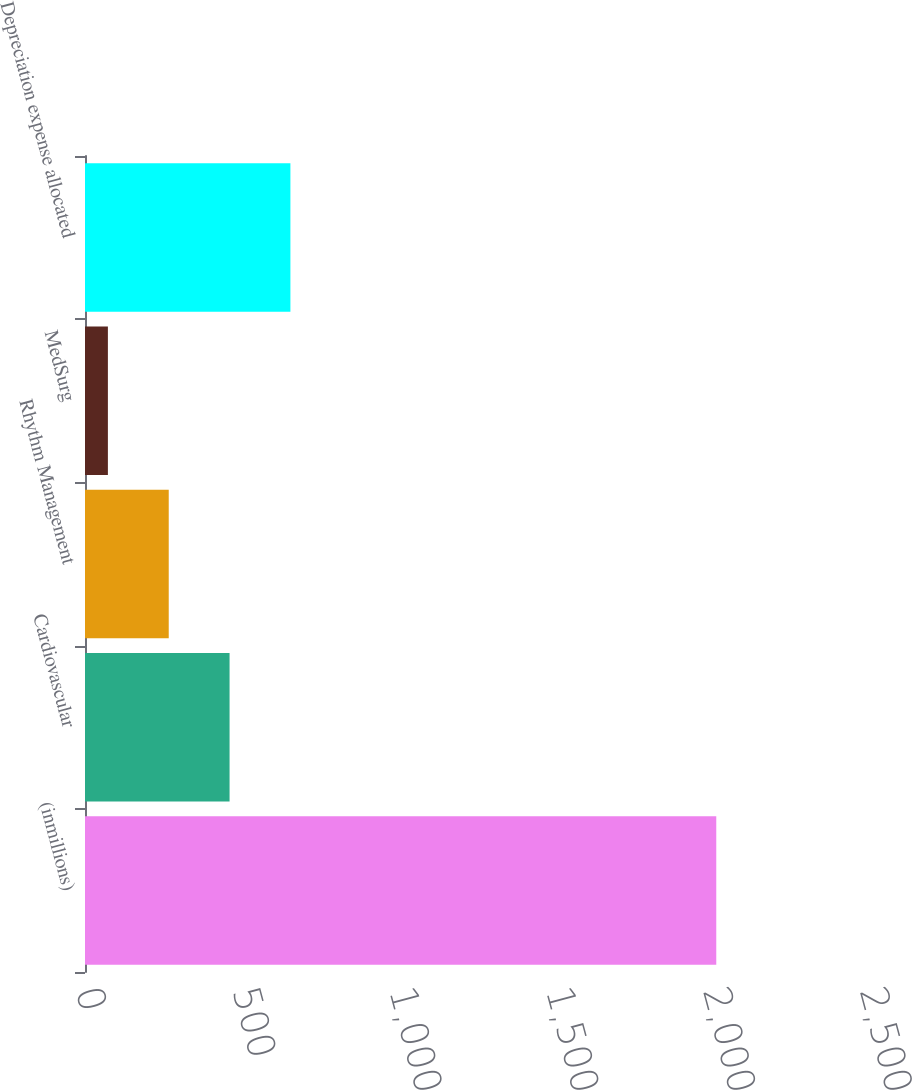Convert chart. <chart><loc_0><loc_0><loc_500><loc_500><bar_chart><fcel>(inmillions)<fcel>Cardiovascular<fcel>Rhythm Management<fcel>MedSurg<fcel>Depreciation expense allocated<nl><fcel>2013<fcel>461<fcel>267<fcel>73<fcel>655<nl></chart> 